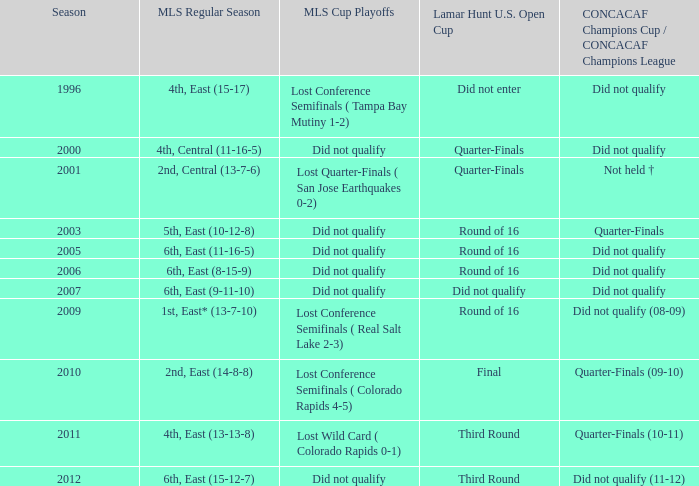What was the mls cup playoffs when the concacaf champions cup/concacaf champions league reached the quarter-finals (09-10)? Lost Conference Semifinals ( Colorado Rapids 4-5). 